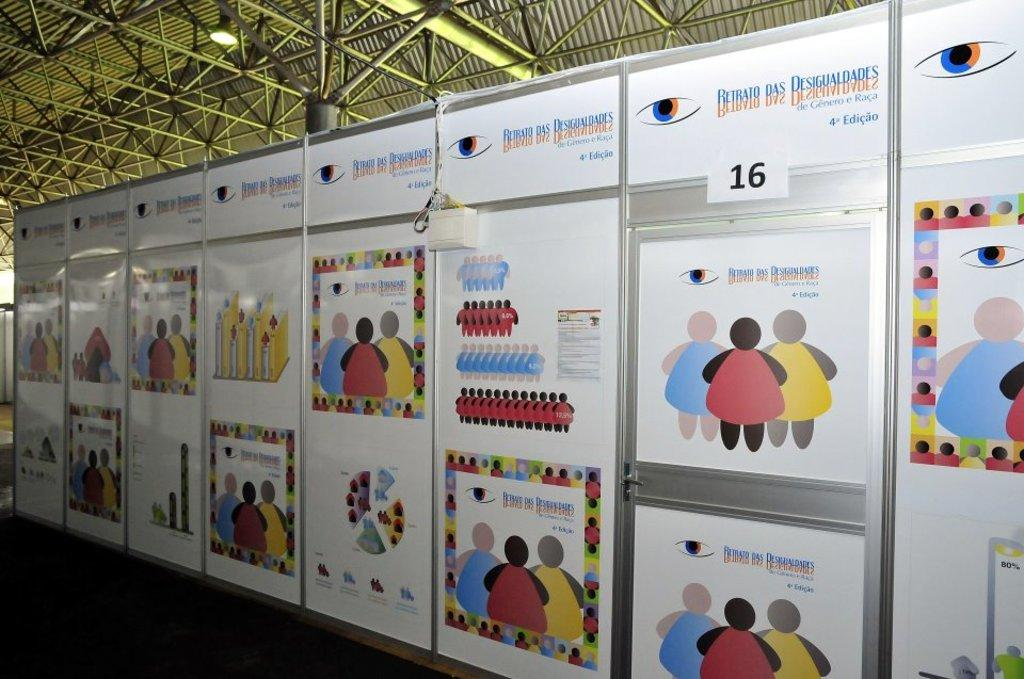<image>
Share a concise interpretation of the image provided. A wall of posters featuring cartoon people for Retrato das Desigualdades. 